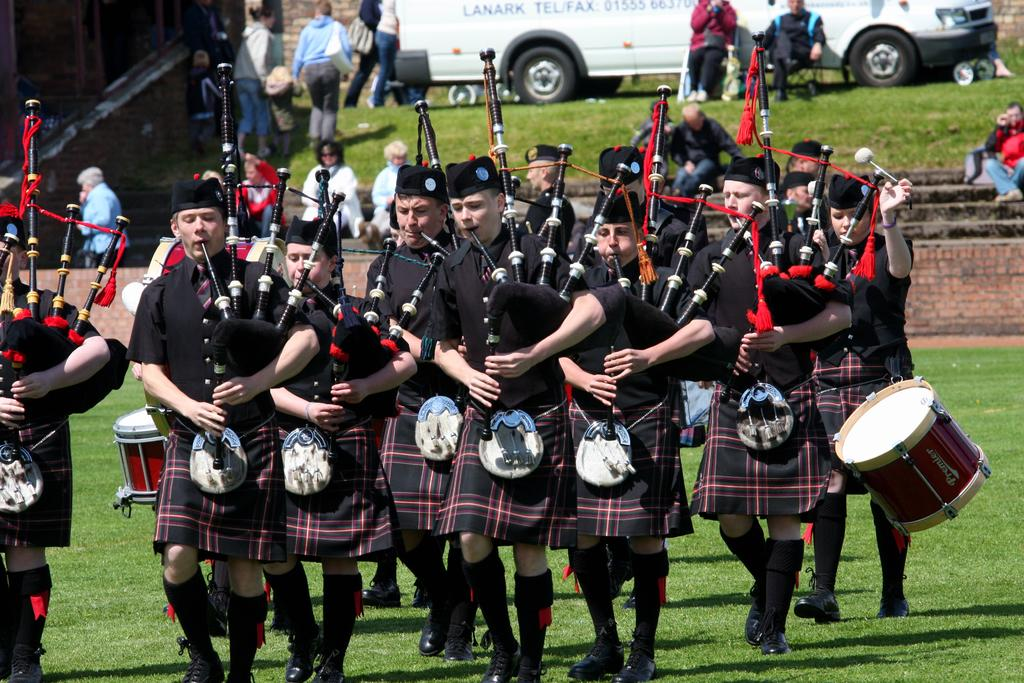What is happening in the image involving the group of people? The people in the image are playing musical instruments. What type of activity are the people engaged in? They are playing musical instruments, which suggests they might be a band or a group of musicians. What can be seen in the background of the image? There is a vehicle in the background of the image. What color is the playground equipment in the image? There is no playground equipment present in the image. What type of vessel is being used by the musicians in the image? The musicians are not using any vessel in the image; they are playing musical instruments. 